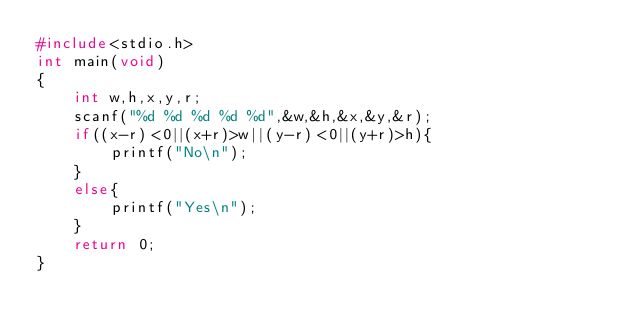Convert code to text. <code><loc_0><loc_0><loc_500><loc_500><_C_>#include<stdio.h>
int main(void)
{
    int w,h,x,y,r;
    scanf("%d %d %d %d %d",&w,&h,&x,&y,&r);
    if((x-r)<0||(x+r)>w||(y-r)<0||(y+r)>h){
		printf("No\n");
    }
    else{
        printf("Yes\n");
    }
    return 0;
}</code> 